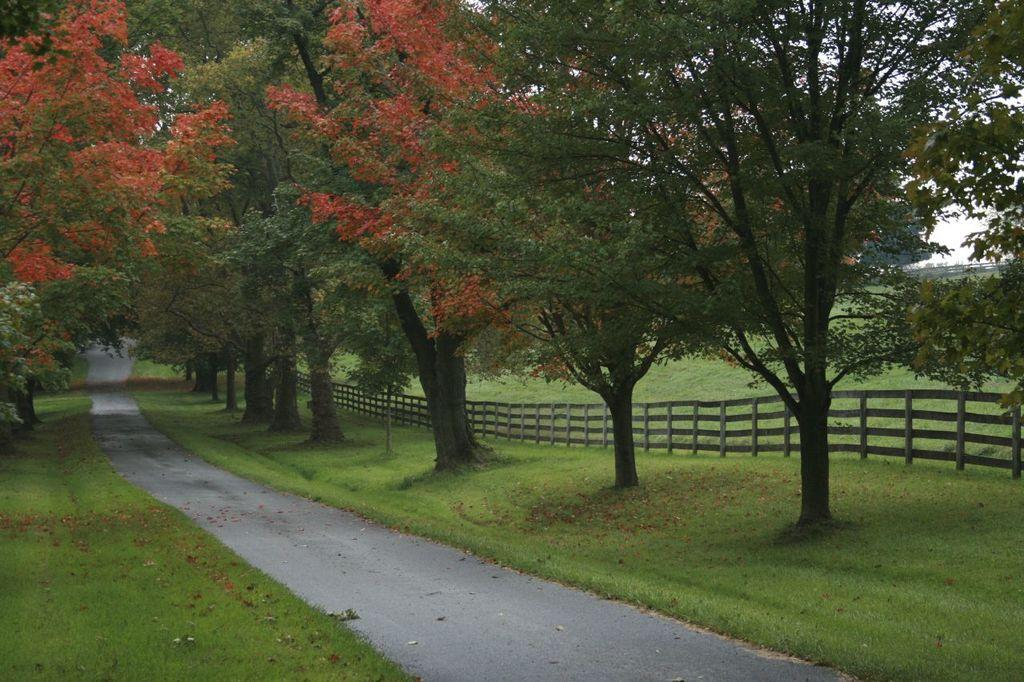What type of vegetation can be seen in the image? There are trees in the image. What structure is present in the image? There is a pole in the image. What type of barrier can be seen in the image? There is a fence in the image. What is visible at the bottom of the image? The ground is visible at the bottom of the image. What type of pathway is present in the image? There is a road in the image. Can you see any islands in the image? There is no island present in the image. What type of flame can be seen coming from the trees in the image? There is no flame present in the image; it only features trees, a pole, a fence, the ground, and a road. 